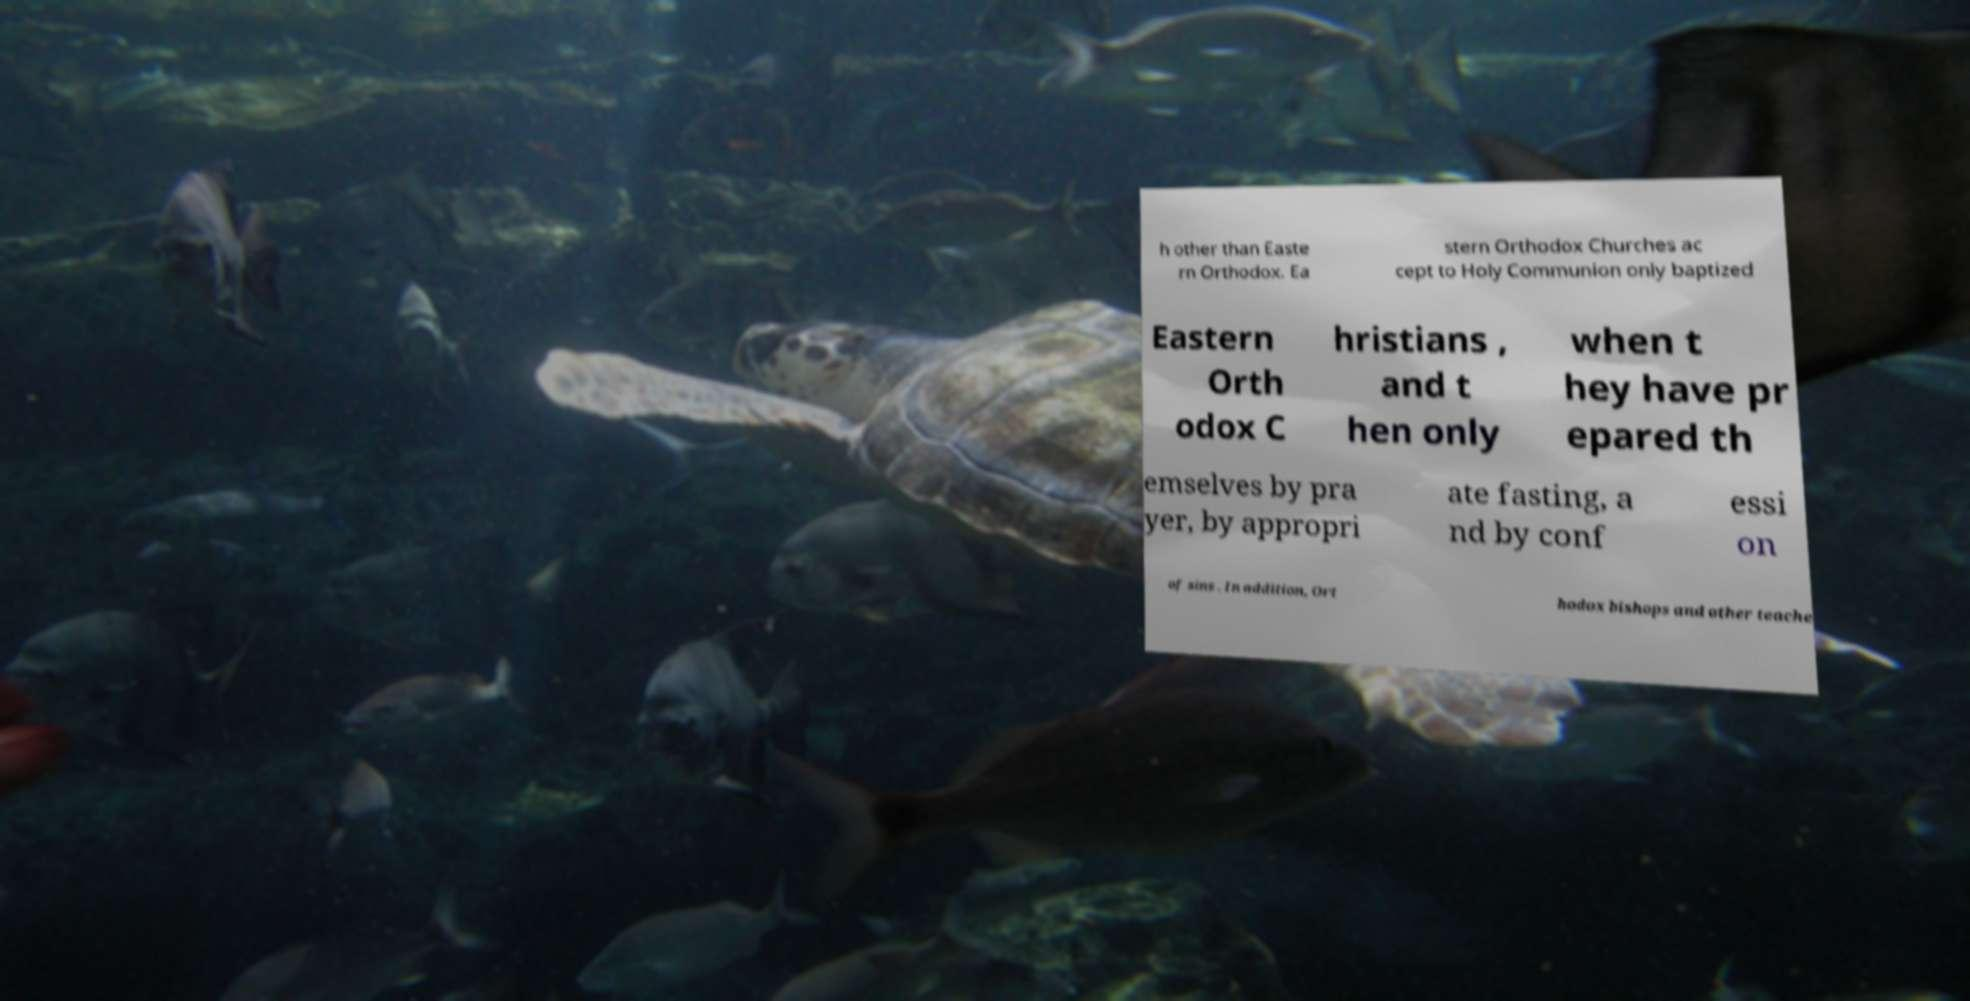Can you read and provide the text displayed in the image?This photo seems to have some interesting text. Can you extract and type it out for me? h other than Easte rn Orthodox. Ea stern Orthodox Churches ac cept to Holy Communion only baptized Eastern Orth odox C hristians , and t hen only when t hey have pr epared th emselves by pra yer, by appropri ate fasting, a nd by conf essi on of sins . In addition, Ort hodox bishops and other teache 